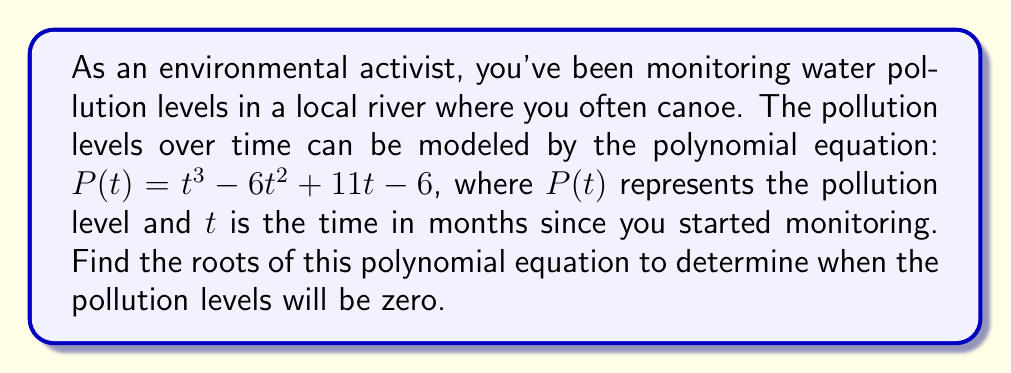What is the answer to this math problem? To find the roots of the polynomial equation $P(t) = t^3 - 6t^2 + 11t - 6$, we need to factor it.

Step 1: Check for rational roots using the rational root theorem.
Possible rational roots: $\pm 1, \pm 2, \pm 3, \pm 6$

Step 2: Use synthetic division to test these roots.
We find that 1 is a root:

$$
\begin{array}{r|r}
1 & 1 \quad -6 \quad 11 \quad -6 \\
  & 1 \quad -5 \quad 6 \\
\hline
  & 1 \quad -5 \quad 6 \quad 0
\end{array}
$$

Step 3: Factor out $(t-1)$:
$P(t) = (t-1)(t^2 - 5t + 6)$

Step 4: Factor the quadratic term $t^2 - 5t + 6$:
$t^2 - 5t + 6 = (t-2)(t-3)$

Step 5: Write the fully factored polynomial:
$P(t) = (t-1)(t-2)(t-3)$

Therefore, the roots of the polynomial are $t = 1$, $t = 2$, and $t = 3$.
Answer: $t = 1, 2, 3$ 